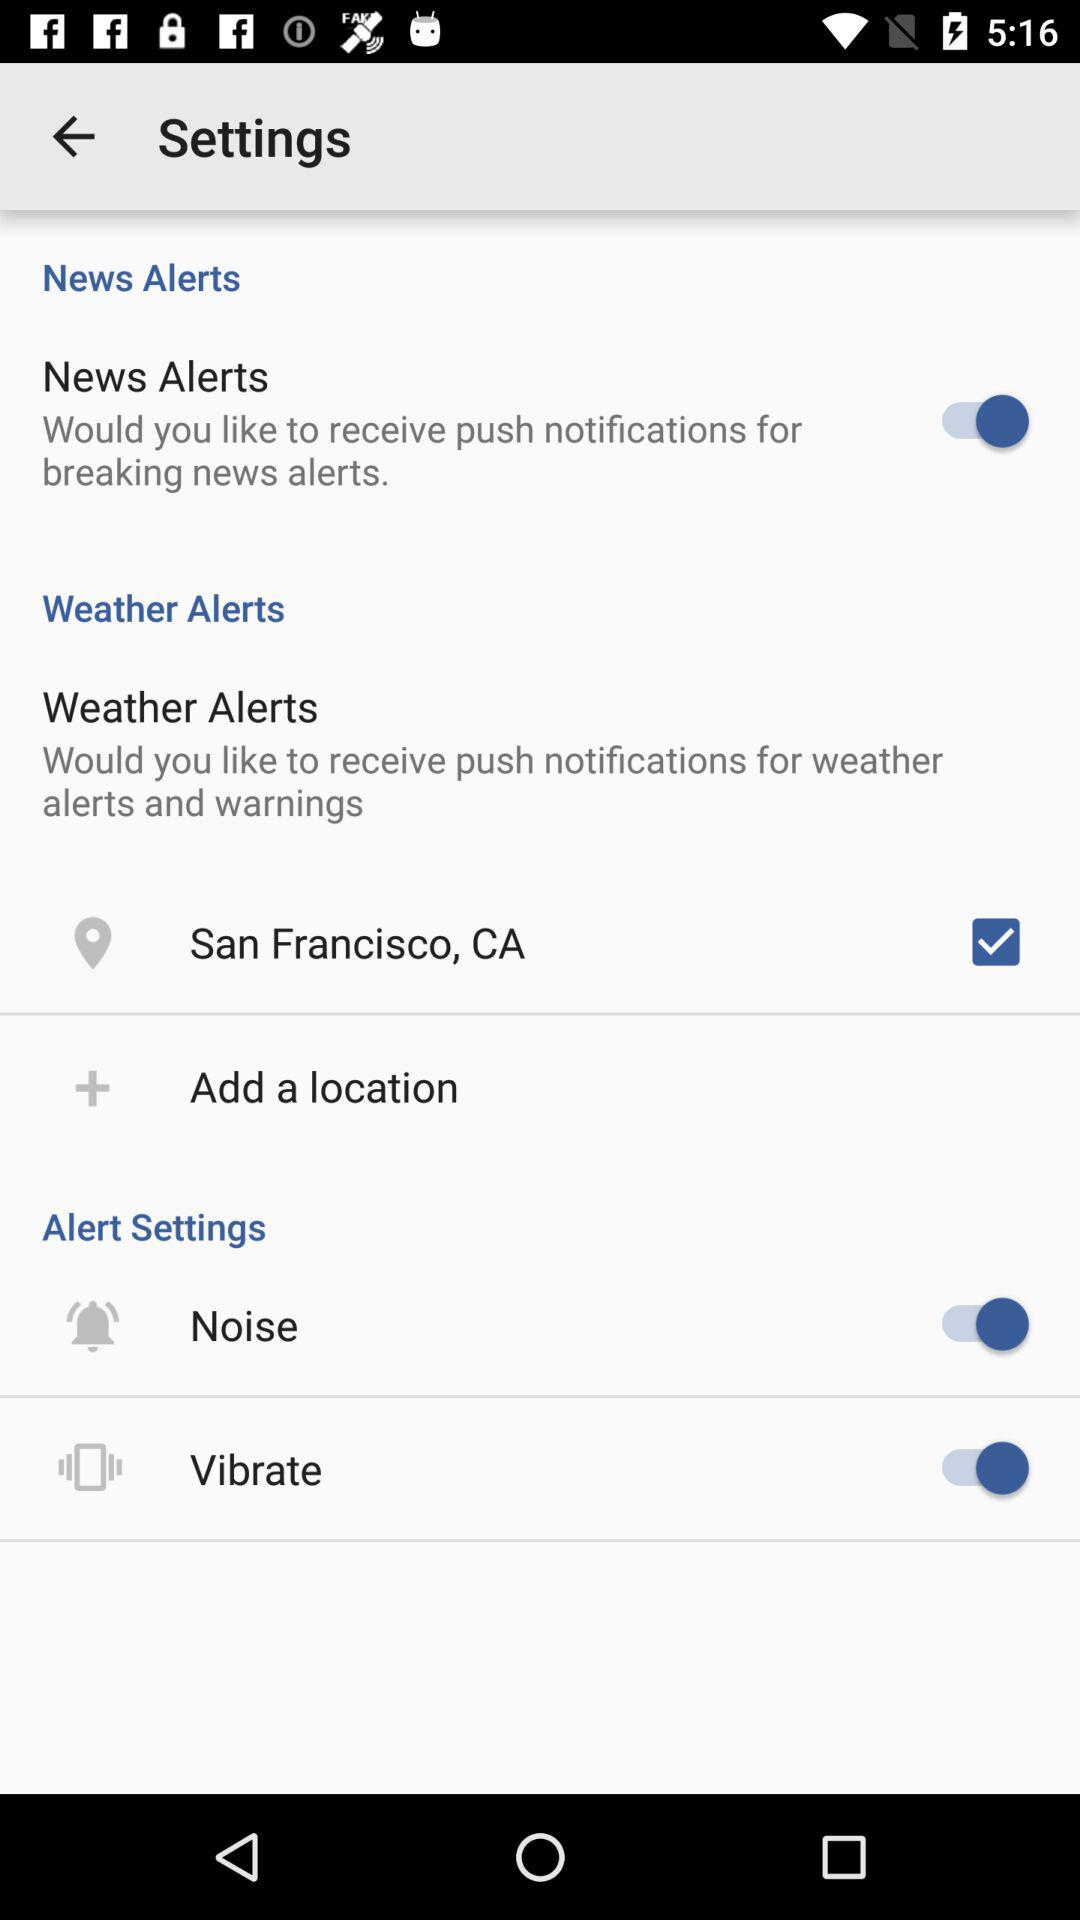Which are the 2 options in the Alert settings? The 2 options are "Noise" and "Vibrate". 